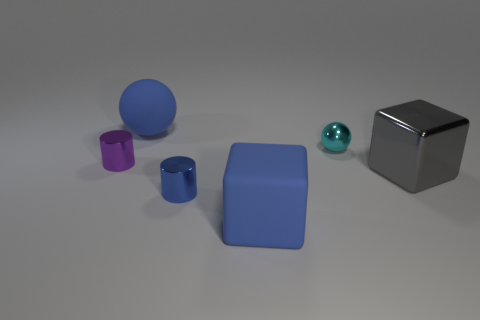Add 2 large red cylinders. How many objects exist? 8 Subtract all cubes. How many objects are left? 4 Subtract 1 blue cylinders. How many objects are left? 5 Subtract all tiny brown metal balls. Subtract all purple cylinders. How many objects are left? 5 Add 5 blue cubes. How many blue cubes are left? 6 Add 5 big metallic cubes. How many big metallic cubes exist? 6 